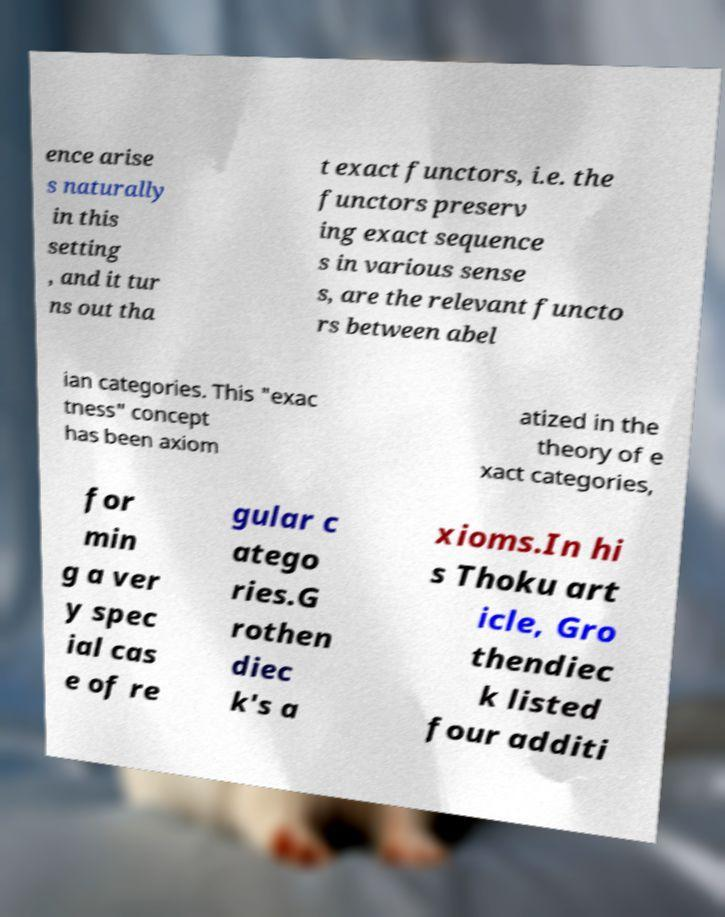Could you extract and type out the text from this image? ence arise s naturally in this setting , and it tur ns out tha t exact functors, i.e. the functors preserv ing exact sequence s in various sense s, are the relevant functo rs between abel ian categories. This "exac tness" concept has been axiom atized in the theory of e xact categories, for min g a ver y spec ial cas e of re gular c atego ries.G rothen diec k's a xioms.In hi s Thoku art icle, Gro thendiec k listed four additi 